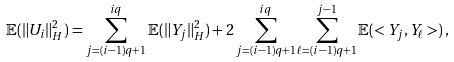<formula> <loc_0><loc_0><loc_500><loc_500>{ \mathbb { E } } ( \| U _ { i } \| _ { H } ^ { 2 } ) = \sum _ { j = ( i - 1 ) q + 1 } ^ { i q } { \mathbb { E } } ( \| Y _ { j } \| _ { H } ^ { 2 } ) + 2 \sum _ { j = ( i - 1 ) q + 1 } ^ { i q } \sum _ { \ell = ( i - 1 ) q + 1 } ^ { j - 1 } { \mathbb { E } } ( < Y _ { j } , Y _ { \ell } > ) \, ,</formula> 